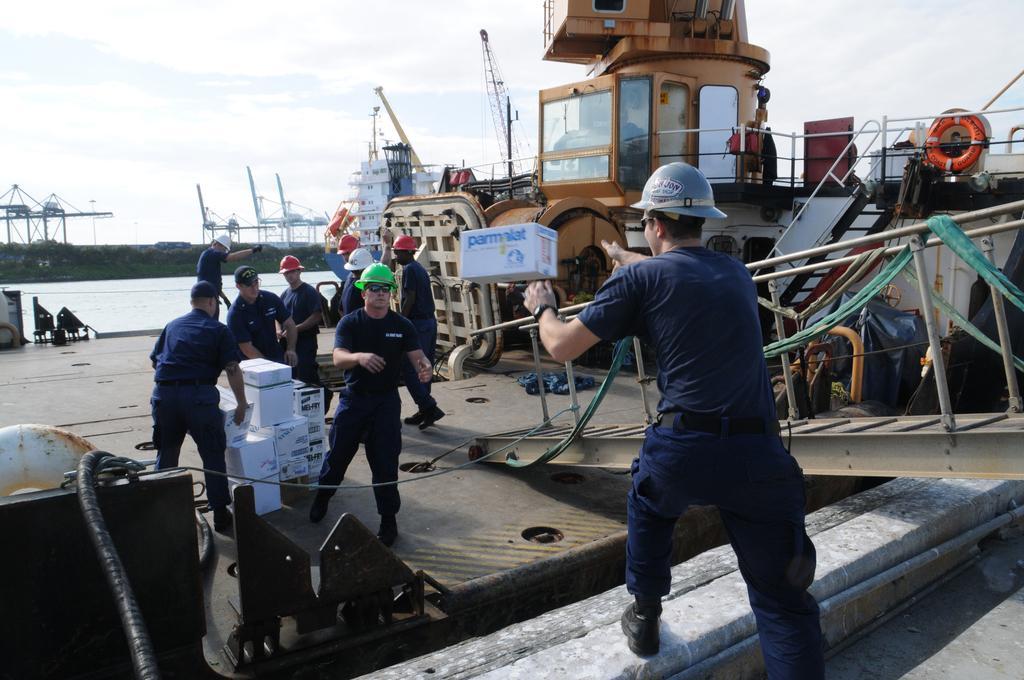Can you describe this image briefly? In this image we can see ships at the deck, men standing on the floor, cardboard cartons, water, trees and sky with clouds. 